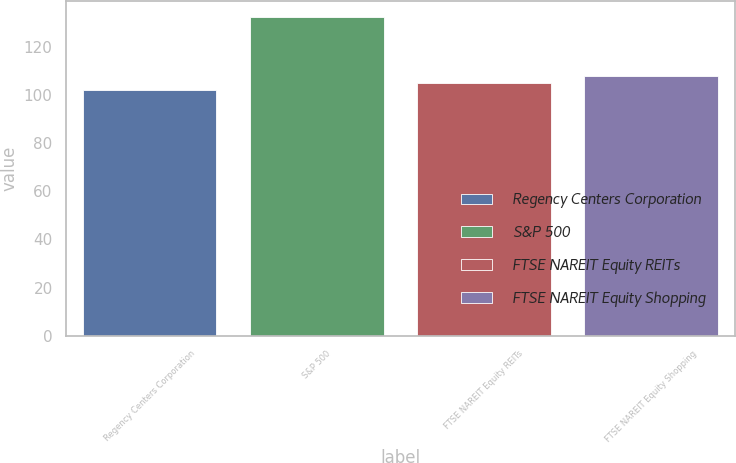Convert chart. <chart><loc_0><loc_0><loc_500><loc_500><bar_chart><fcel>Regency Centers Corporation<fcel>S&P 500<fcel>FTSE NAREIT Equity REITs<fcel>FTSE NAREIT Equity Shopping<nl><fcel>101.81<fcel>132.39<fcel>104.87<fcel>107.93<nl></chart> 